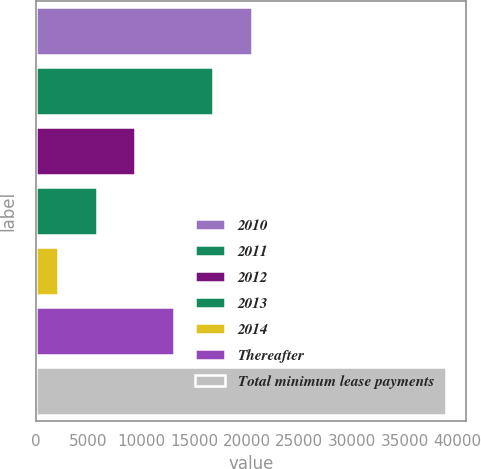<chart> <loc_0><loc_0><loc_500><loc_500><bar_chart><fcel>2010<fcel>2011<fcel>2012<fcel>2013<fcel>2014<fcel>Thereafter<fcel>Total minimum lease payments<nl><fcel>20482.5<fcel>16801.8<fcel>9440.4<fcel>5759.7<fcel>2079<fcel>13121.1<fcel>38886<nl></chart> 